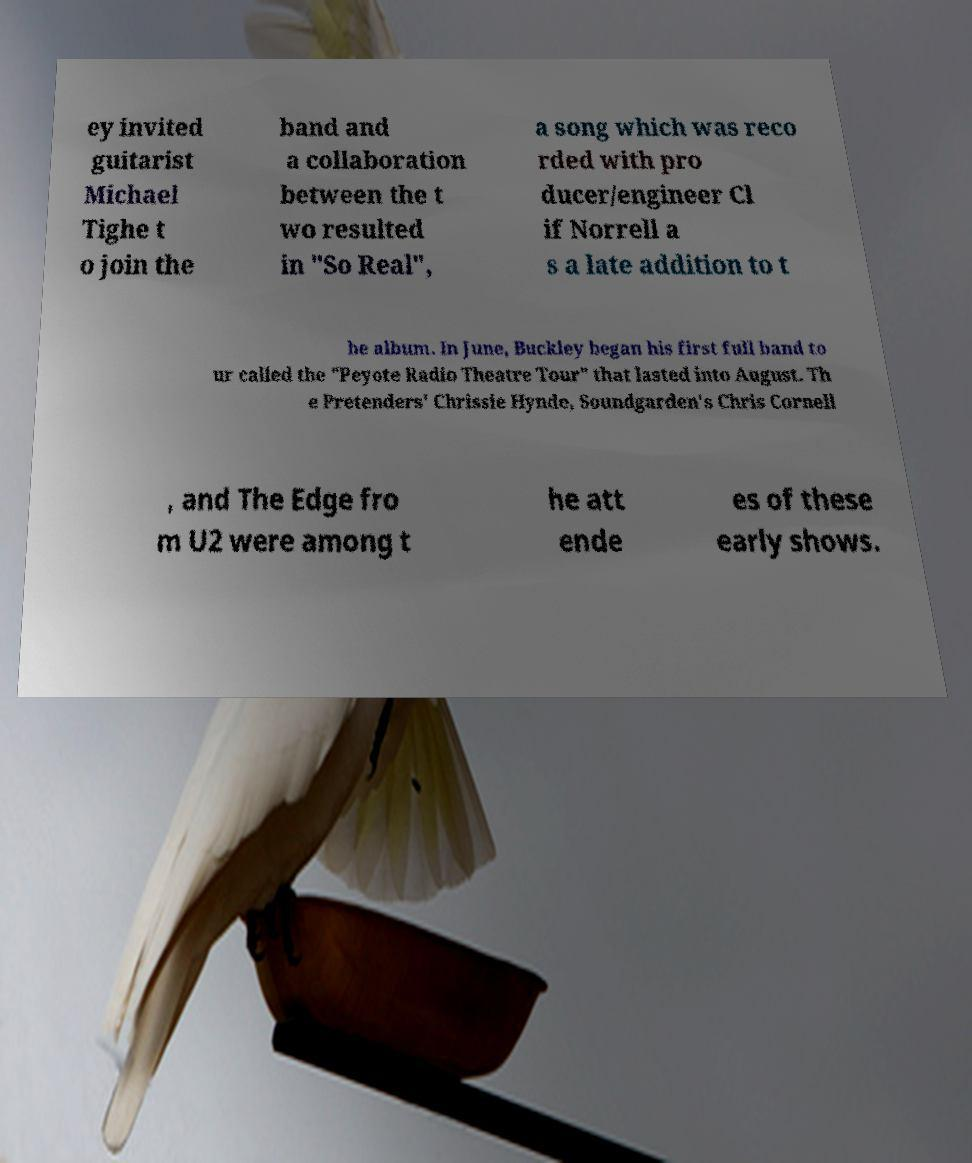I need the written content from this picture converted into text. Can you do that? ey invited guitarist Michael Tighe t o join the band and a collaboration between the t wo resulted in "So Real", a song which was reco rded with pro ducer/engineer Cl if Norrell a s a late addition to t he album. In June, Buckley began his first full band to ur called the "Peyote Radio Theatre Tour" that lasted into August. Th e Pretenders' Chrissie Hynde, Soundgarden's Chris Cornell , and The Edge fro m U2 were among t he att ende es of these early shows. 